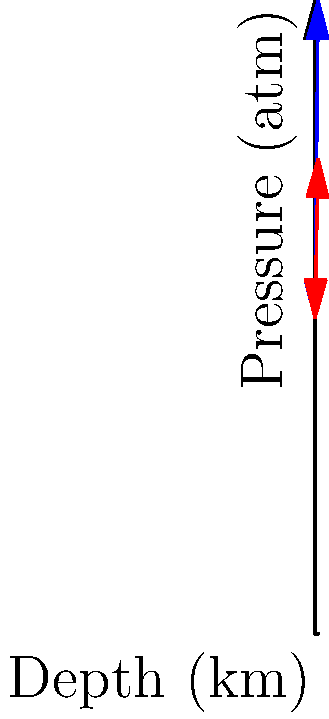A hydraulic system used in oil extraction experiences different pressures at varying depths. The graph shows the pressure-depth relationship for offshore rigs in Trinidad and the Persian Gulf. If the pressure at a depth of 5 km in Trinidad's rig is 1500 atm, what is the pressure difference between Trinidad's rig and the Persian Gulf rig at a depth of 8 km? Let's approach this step-by-step:

1) From the graph, we can see that the pressure increases linearly with depth for both locations.

2) For Trinidad's rig:
   - At 0 km: Pressure = 1000 atm
   - At 5 km: Pressure = 1500 atm
   
   We can calculate the rate of pressure increase:
   $\frac{1500 - 1000}{5} = 100$ atm/km

3) The equation for Trinidad's pressure (P_T) at depth d is:
   $P_T = 1000 + 100d$

4) At 8 km depth for Trinidad:
   $P_T = 1000 + 100(8) = 1800$ atm

5) For the Persian Gulf rig, we can see the line has a smaller slope.
   The equation appears to be:
   $P_G = 1000 + 50d$

6) At 8 km depth for Persian Gulf:
   $P_G = 1000 + 50(8) = 1400$ atm

7) The pressure difference at 8 km:
   $1800 - 1400 = 400$ atm

Therefore, at 8 km depth, the pressure in Trinidad's rig is 400 atm higher than in the Persian Gulf rig.
Answer: 400 atm 